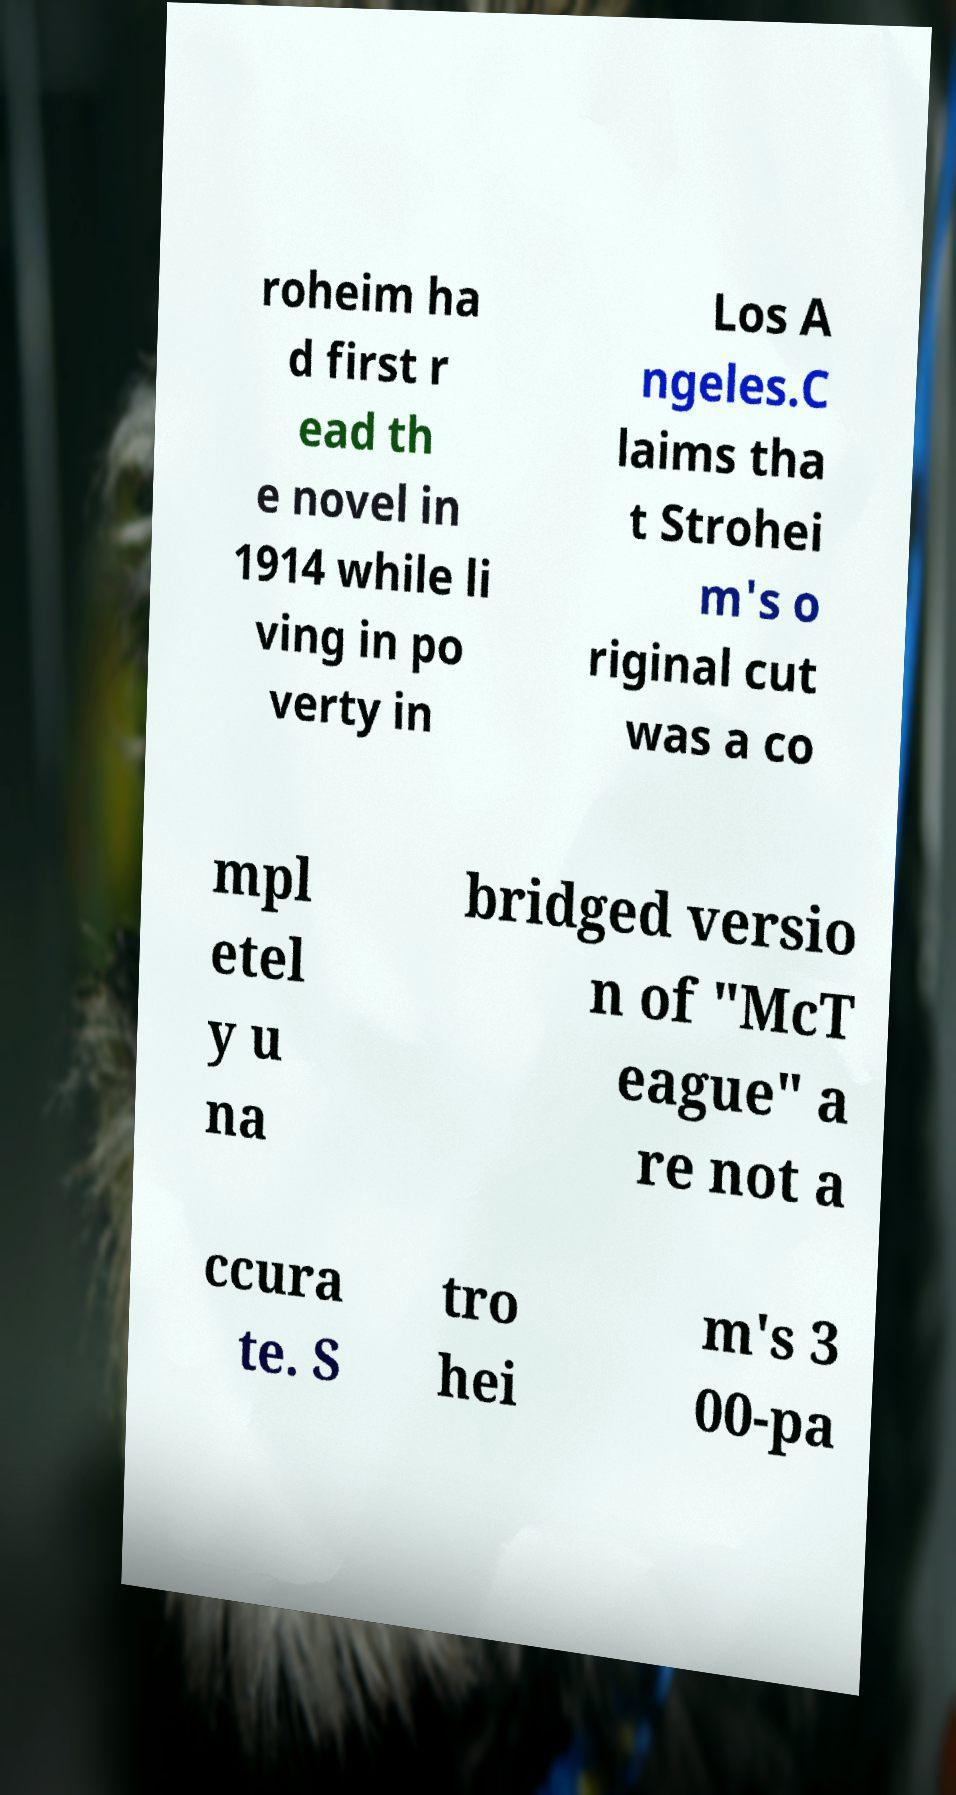Please read and relay the text visible in this image. What does it say? roheim ha d first r ead th e novel in 1914 while li ving in po verty in Los A ngeles.C laims tha t Strohei m's o riginal cut was a co mpl etel y u na bridged versio n of "McT eague" a re not a ccura te. S tro hei m's 3 00-pa 